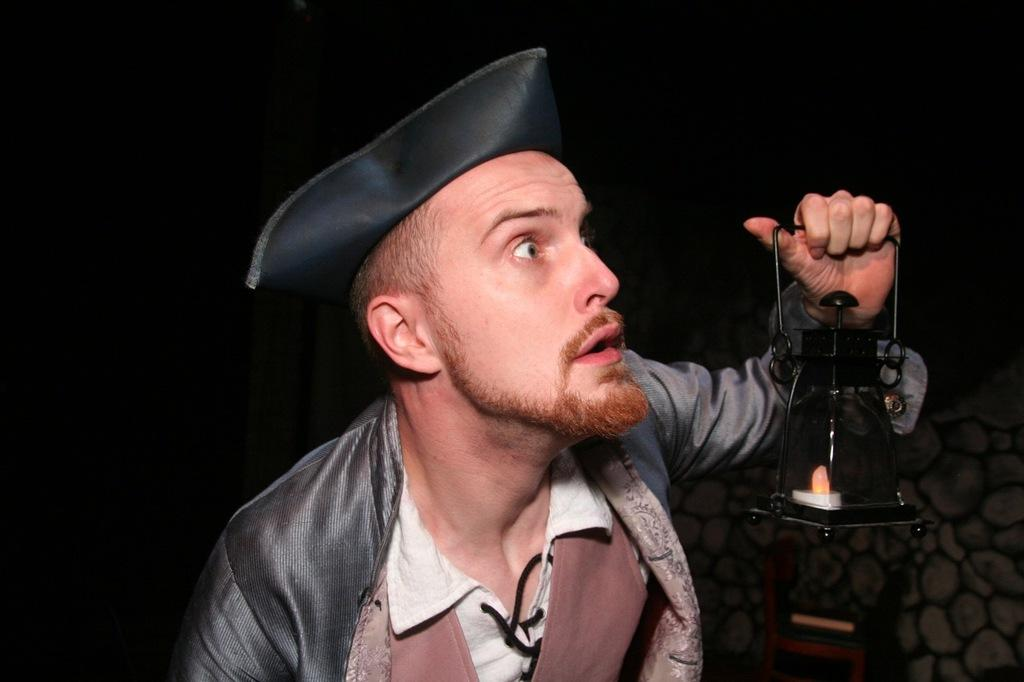Who is present in the image? There is a man in the image. What is the man holding in the image? The man is holding a lantern lamp in the image. What is the man wearing on his head? The man is wearing a wire cap in the image. What can be seen in the background of the image? There is a wall in the background of the image. What type of knowledge can be seen in the image? There is no specific knowledge depicted in the image; it features a man holding a lantern lamp and wearing a wire cap. How many stars are visible in the image? There are no stars visible in the image; it is focused on the man and the wall in the background. 